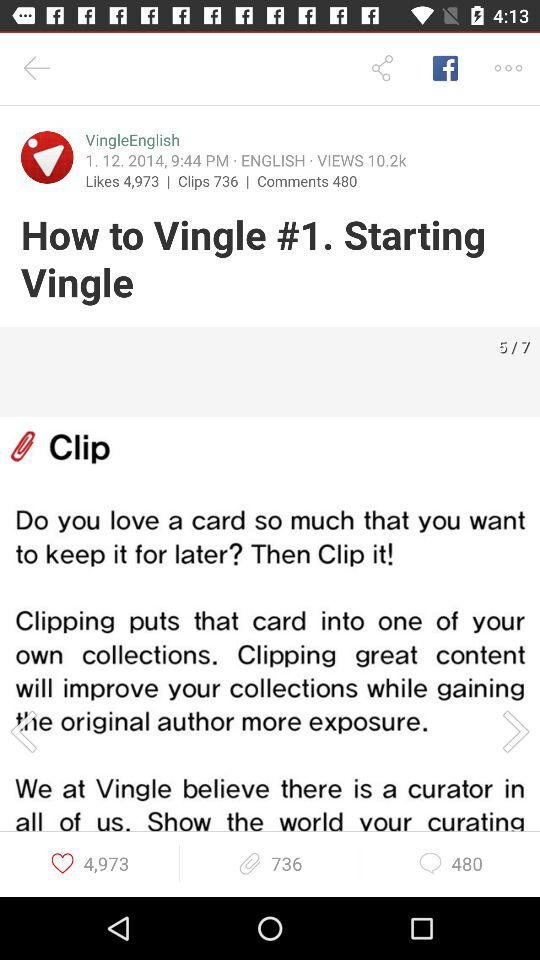How many comments are there? There are 480 comments. 